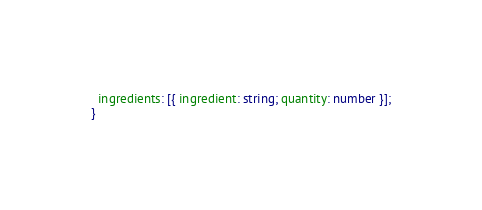<code> <loc_0><loc_0><loc_500><loc_500><_TypeScript_>  ingredients: [{ ingredient: string; quantity: number }];
}
</code> 